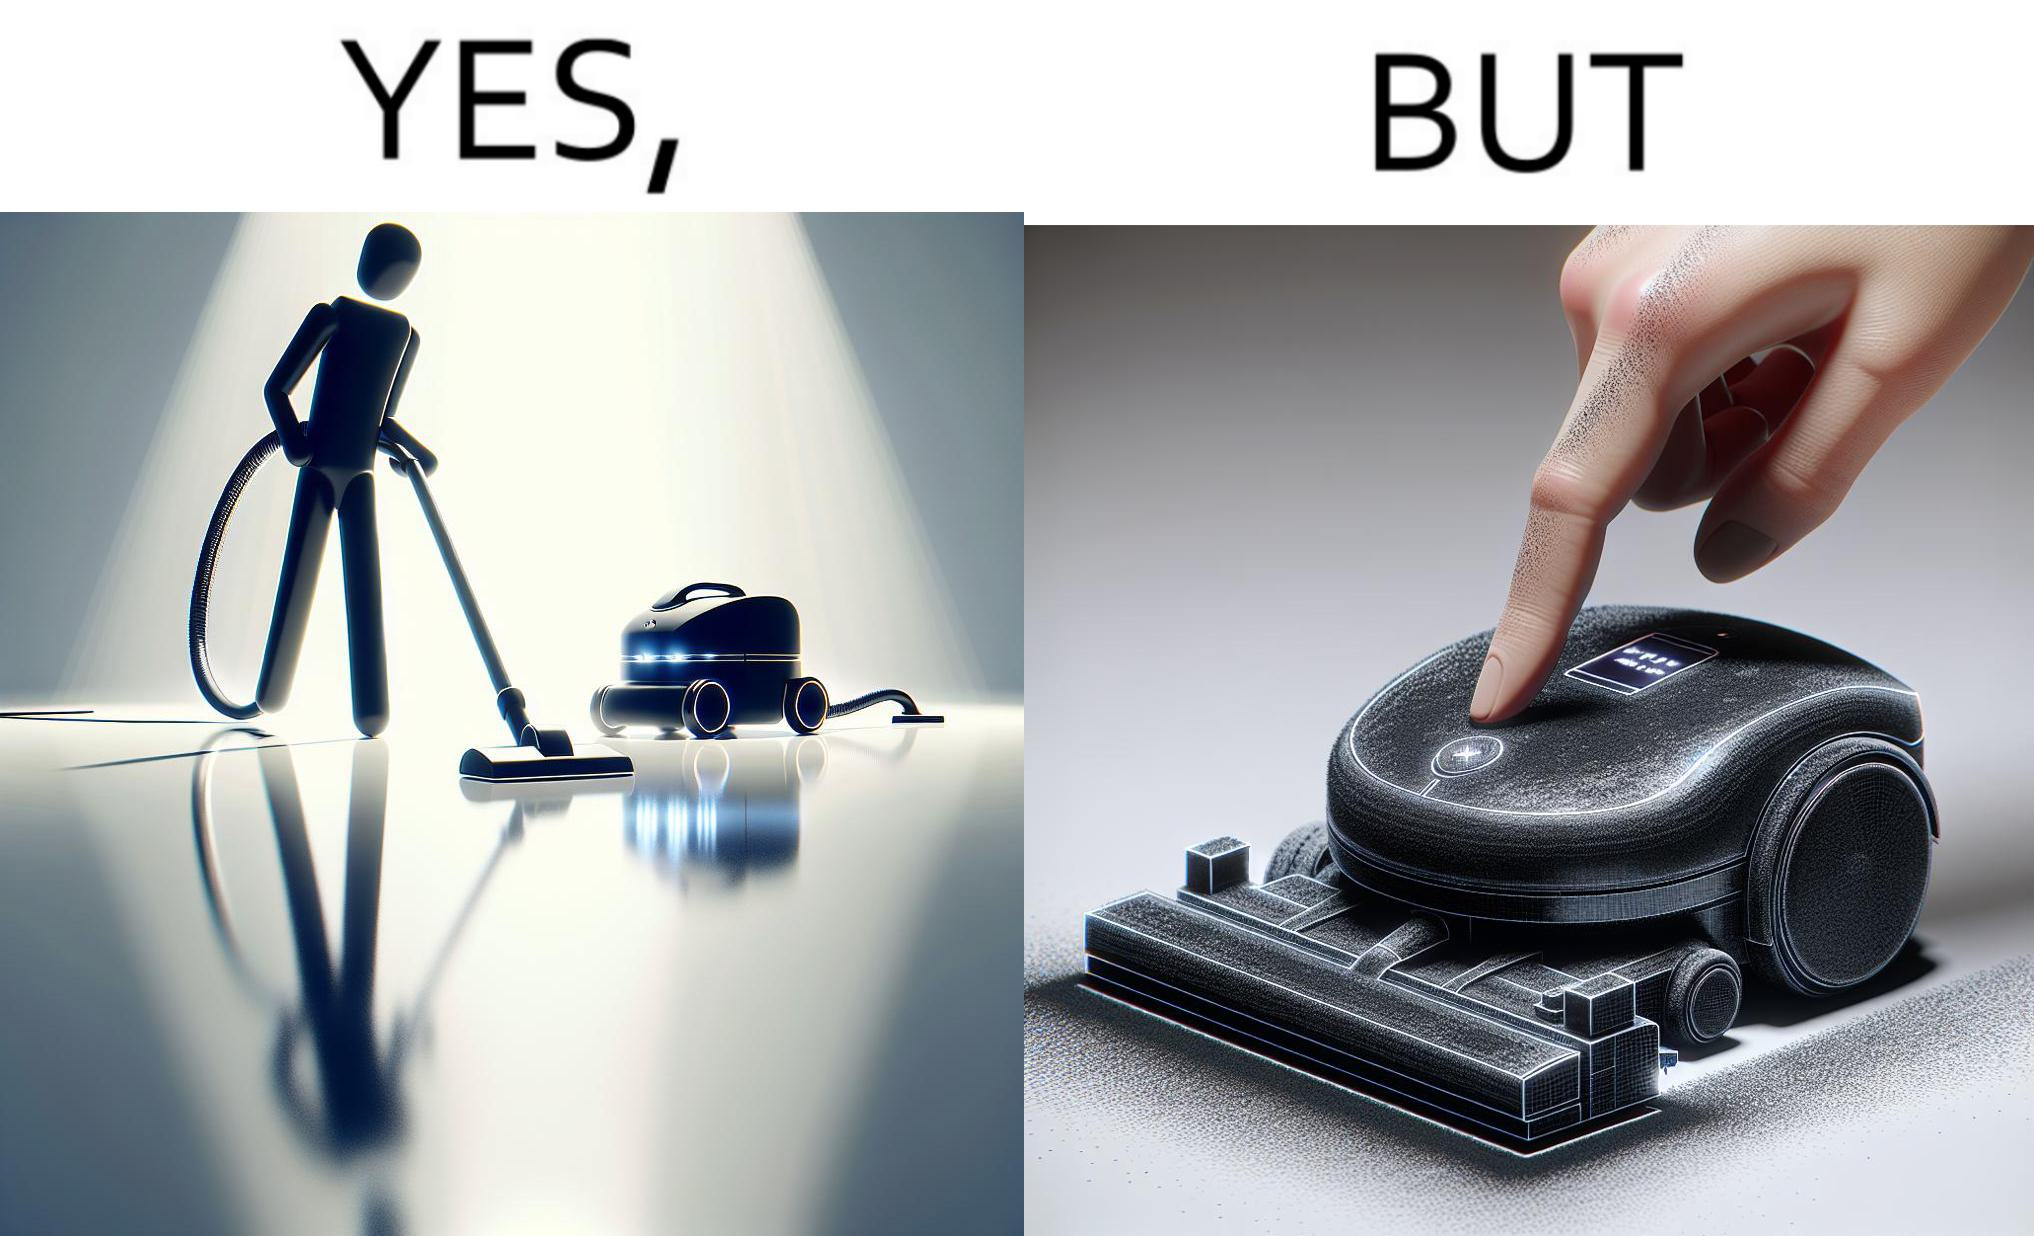What makes this image funny or satirical? This is funny, because the machine while doing its job cleans everything but ends up being dirty itself. 